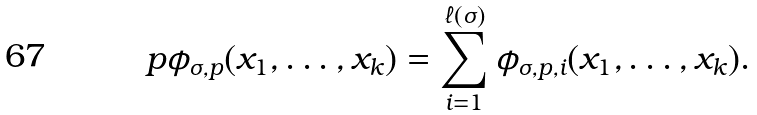<formula> <loc_0><loc_0><loc_500><loc_500>p \phi _ { \sigma , p } ( x _ { 1 } , \dots , x _ { k } ) = \sum ^ { \ell ( \sigma ) } _ { i = 1 } \phi _ { \sigma , p , i } ( x _ { 1 } , \dots , x _ { k } ) .</formula> 